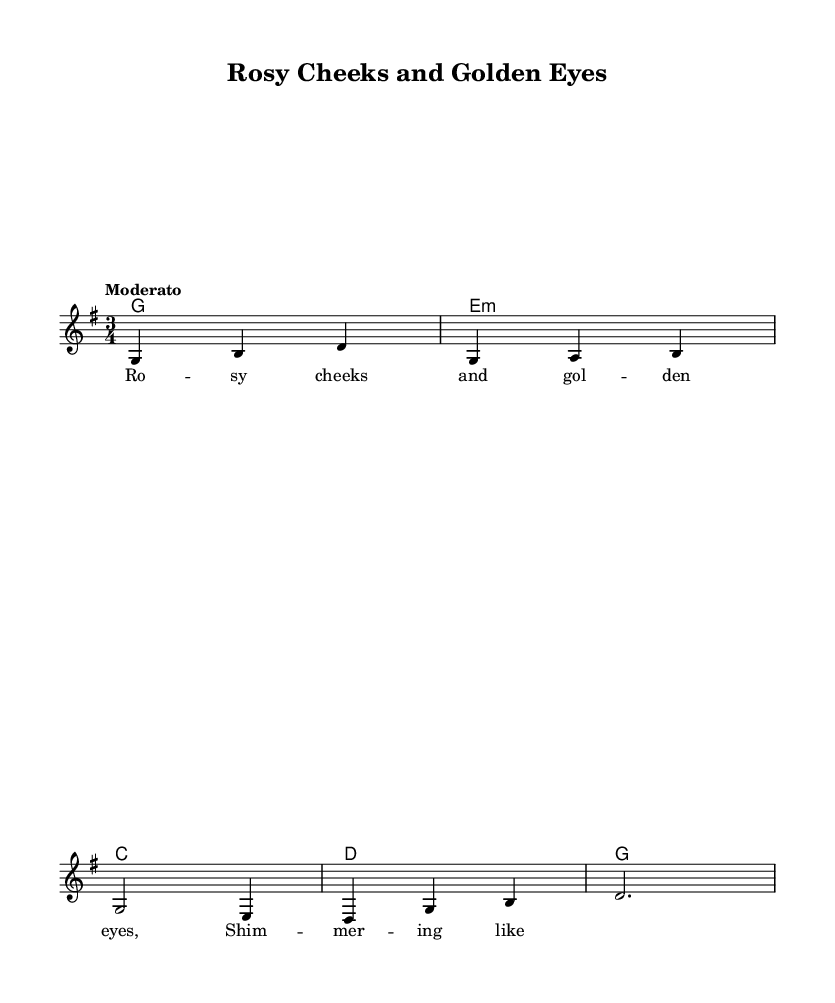What is the key signature of this music? The key signature is G major, which has one sharp (F#).
Answer: G major What is the time signature of this piece? The time signature is 3/4, indicating three beats per measure.
Answer: 3/4 What is the tempo marking for this music? The tempo marking is "Moderato," which suggests a moderate speed.
Answer: Moderato How many measures are in the melody? The melody consists of five measures, as counted from the notation.
Answer: Five What style of music does this piece represent? This piece represents Folk music, characterized by its simplicity and traditional themes.
Answer: Folk What two visual elements inspired the lyrics of this folk tune? The lyrics are inspired by "Rosy cheeks" and "Golden eyes," reflecting color palettes and makeup trends.
Answer: Rosy cheeks and Golden eyes How many chords are used in the harmony section? The harmony section uses four chords: G, E minor, C, and D.
Answer: Four 